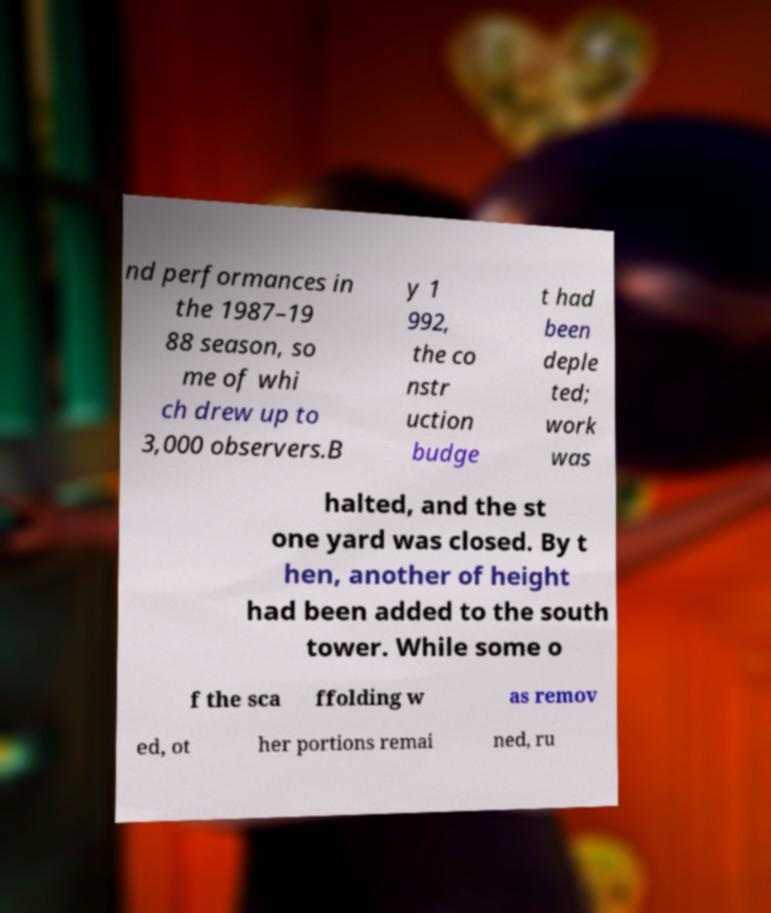For documentation purposes, I need the text within this image transcribed. Could you provide that? nd performances in the 1987–19 88 season, so me of whi ch drew up to 3,000 observers.B y 1 992, the co nstr uction budge t had been deple ted; work was halted, and the st one yard was closed. By t hen, another of height had been added to the south tower. While some o f the sca ffolding w as remov ed, ot her portions remai ned, ru 